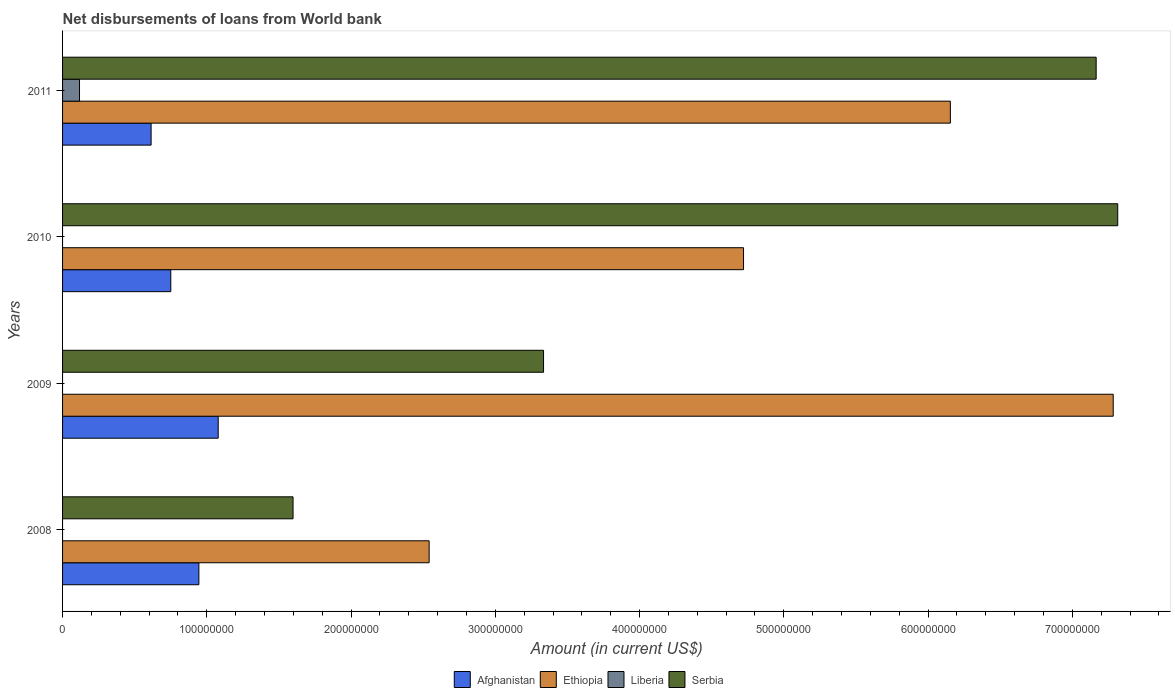How many different coloured bars are there?
Provide a short and direct response. 4. How many groups of bars are there?
Make the answer very short. 4. Are the number of bars on each tick of the Y-axis equal?
Offer a terse response. No. How many bars are there on the 2nd tick from the top?
Your response must be concise. 3. How many bars are there on the 4th tick from the bottom?
Offer a very short reply. 4. What is the label of the 1st group of bars from the top?
Give a very brief answer. 2011. In how many cases, is the number of bars for a given year not equal to the number of legend labels?
Offer a very short reply. 3. What is the amount of loan disbursed from World Bank in Afghanistan in 2008?
Your answer should be very brief. 9.45e+07. Across all years, what is the maximum amount of loan disbursed from World Bank in Liberia?
Make the answer very short. 1.17e+07. Across all years, what is the minimum amount of loan disbursed from World Bank in Afghanistan?
Your answer should be very brief. 6.14e+07. What is the total amount of loan disbursed from World Bank in Liberia in the graph?
Provide a succinct answer. 1.17e+07. What is the difference between the amount of loan disbursed from World Bank in Ethiopia in 2008 and that in 2010?
Your answer should be compact. -2.18e+08. What is the difference between the amount of loan disbursed from World Bank in Afghanistan in 2011 and the amount of loan disbursed from World Bank in Ethiopia in 2008?
Your answer should be very brief. -1.93e+08. What is the average amount of loan disbursed from World Bank in Serbia per year?
Provide a short and direct response. 4.85e+08. In the year 2009, what is the difference between the amount of loan disbursed from World Bank in Ethiopia and amount of loan disbursed from World Bank in Afghanistan?
Provide a succinct answer. 6.20e+08. What is the ratio of the amount of loan disbursed from World Bank in Ethiopia in 2008 to that in 2010?
Keep it short and to the point. 0.54. Is the amount of loan disbursed from World Bank in Serbia in 2008 less than that in 2009?
Make the answer very short. Yes. Is the difference between the amount of loan disbursed from World Bank in Ethiopia in 2008 and 2011 greater than the difference between the amount of loan disbursed from World Bank in Afghanistan in 2008 and 2011?
Make the answer very short. No. What is the difference between the highest and the second highest amount of loan disbursed from World Bank in Afghanistan?
Offer a very short reply. 1.34e+07. What is the difference between the highest and the lowest amount of loan disbursed from World Bank in Serbia?
Offer a very short reply. 5.72e+08. In how many years, is the amount of loan disbursed from World Bank in Afghanistan greater than the average amount of loan disbursed from World Bank in Afghanistan taken over all years?
Provide a succinct answer. 2. Is it the case that in every year, the sum of the amount of loan disbursed from World Bank in Afghanistan and amount of loan disbursed from World Bank in Serbia is greater than the sum of amount of loan disbursed from World Bank in Liberia and amount of loan disbursed from World Bank in Ethiopia?
Your response must be concise. Yes. Is it the case that in every year, the sum of the amount of loan disbursed from World Bank in Serbia and amount of loan disbursed from World Bank in Ethiopia is greater than the amount of loan disbursed from World Bank in Liberia?
Make the answer very short. Yes. How many years are there in the graph?
Offer a terse response. 4. What is the difference between two consecutive major ticks on the X-axis?
Offer a terse response. 1.00e+08. Are the values on the major ticks of X-axis written in scientific E-notation?
Your response must be concise. No. Does the graph contain any zero values?
Offer a terse response. Yes. Does the graph contain grids?
Provide a short and direct response. No. Where does the legend appear in the graph?
Provide a short and direct response. Bottom center. What is the title of the graph?
Your answer should be compact. Net disbursements of loans from World bank. What is the label or title of the Y-axis?
Your answer should be very brief. Years. What is the Amount (in current US$) in Afghanistan in 2008?
Provide a succinct answer. 9.45e+07. What is the Amount (in current US$) in Ethiopia in 2008?
Your answer should be very brief. 2.54e+08. What is the Amount (in current US$) in Serbia in 2008?
Offer a terse response. 1.60e+08. What is the Amount (in current US$) in Afghanistan in 2009?
Give a very brief answer. 1.08e+08. What is the Amount (in current US$) of Ethiopia in 2009?
Your response must be concise. 7.28e+08. What is the Amount (in current US$) in Liberia in 2009?
Keep it short and to the point. 0. What is the Amount (in current US$) of Serbia in 2009?
Your answer should be very brief. 3.33e+08. What is the Amount (in current US$) of Afghanistan in 2010?
Offer a terse response. 7.50e+07. What is the Amount (in current US$) of Ethiopia in 2010?
Offer a very short reply. 4.72e+08. What is the Amount (in current US$) of Serbia in 2010?
Provide a short and direct response. 7.31e+08. What is the Amount (in current US$) in Afghanistan in 2011?
Ensure brevity in your answer.  6.14e+07. What is the Amount (in current US$) of Ethiopia in 2011?
Provide a succinct answer. 6.15e+08. What is the Amount (in current US$) of Liberia in 2011?
Give a very brief answer. 1.17e+07. What is the Amount (in current US$) in Serbia in 2011?
Offer a terse response. 7.17e+08. Across all years, what is the maximum Amount (in current US$) of Afghanistan?
Offer a very short reply. 1.08e+08. Across all years, what is the maximum Amount (in current US$) in Ethiopia?
Offer a very short reply. 7.28e+08. Across all years, what is the maximum Amount (in current US$) of Liberia?
Your response must be concise. 1.17e+07. Across all years, what is the maximum Amount (in current US$) in Serbia?
Make the answer very short. 7.31e+08. Across all years, what is the minimum Amount (in current US$) in Afghanistan?
Your response must be concise. 6.14e+07. Across all years, what is the minimum Amount (in current US$) in Ethiopia?
Provide a short and direct response. 2.54e+08. Across all years, what is the minimum Amount (in current US$) of Serbia?
Your answer should be very brief. 1.60e+08. What is the total Amount (in current US$) of Afghanistan in the graph?
Offer a terse response. 3.39e+08. What is the total Amount (in current US$) in Ethiopia in the graph?
Give a very brief answer. 2.07e+09. What is the total Amount (in current US$) in Liberia in the graph?
Give a very brief answer. 1.17e+07. What is the total Amount (in current US$) in Serbia in the graph?
Keep it short and to the point. 1.94e+09. What is the difference between the Amount (in current US$) in Afghanistan in 2008 and that in 2009?
Keep it short and to the point. -1.34e+07. What is the difference between the Amount (in current US$) of Ethiopia in 2008 and that in 2009?
Ensure brevity in your answer.  -4.74e+08. What is the difference between the Amount (in current US$) in Serbia in 2008 and that in 2009?
Offer a terse response. -1.74e+08. What is the difference between the Amount (in current US$) of Afghanistan in 2008 and that in 2010?
Make the answer very short. 1.95e+07. What is the difference between the Amount (in current US$) in Ethiopia in 2008 and that in 2010?
Provide a short and direct response. -2.18e+08. What is the difference between the Amount (in current US$) in Serbia in 2008 and that in 2010?
Your answer should be compact. -5.72e+08. What is the difference between the Amount (in current US$) in Afghanistan in 2008 and that in 2011?
Your answer should be compact. 3.31e+07. What is the difference between the Amount (in current US$) in Ethiopia in 2008 and that in 2011?
Provide a short and direct response. -3.61e+08. What is the difference between the Amount (in current US$) of Serbia in 2008 and that in 2011?
Provide a short and direct response. -5.57e+08. What is the difference between the Amount (in current US$) of Afghanistan in 2009 and that in 2010?
Your answer should be very brief. 3.29e+07. What is the difference between the Amount (in current US$) in Ethiopia in 2009 and that in 2010?
Provide a succinct answer. 2.56e+08. What is the difference between the Amount (in current US$) in Serbia in 2009 and that in 2010?
Provide a short and direct response. -3.98e+08. What is the difference between the Amount (in current US$) in Afghanistan in 2009 and that in 2011?
Make the answer very short. 4.65e+07. What is the difference between the Amount (in current US$) in Ethiopia in 2009 and that in 2011?
Your response must be concise. 1.13e+08. What is the difference between the Amount (in current US$) of Serbia in 2009 and that in 2011?
Keep it short and to the point. -3.83e+08. What is the difference between the Amount (in current US$) in Afghanistan in 2010 and that in 2011?
Ensure brevity in your answer.  1.37e+07. What is the difference between the Amount (in current US$) in Ethiopia in 2010 and that in 2011?
Offer a terse response. -1.43e+08. What is the difference between the Amount (in current US$) in Serbia in 2010 and that in 2011?
Offer a terse response. 1.50e+07. What is the difference between the Amount (in current US$) in Afghanistan in 2008 and the Amount (in current US$) in Ethiopia in 2009?
Offer a terse response. -6.34e+08. What is the difference between the Amount (in current US$) in Afghanistan in 2008 and the Amount (in current US$) in Serbia in 2009?
Provide a succinct answer. -2.39e+08. What is the difference between the Amount (in current US$) of Ethiopia in 2008 and the Amount (in current US$) of Serbia in 2009?
Provide a short and direct response. -7.93e+07. What is the difference between the Amount (in current US$) in Afghanistan in 2008 and the Amount (in current US$) in Ethiopia in 2010?
Ensure brevity in your answer.  -3.78e+08. What is the difference between the Amount (in current US$) of Afghanistan in 2008 and the Amount (in current US$) of Serbia in 2010?
Make the answer very short. -6.37e+08. What is the difference between the Amount (in current US$) of Ethiopia in 2008 and the Amount (in current US$) of Serbia in 2010?
Make the answer very short. -4.77e+08. What is the difference between the Amount (in current US$) in Afghanistan in 2008 and the Amount (in current US$) in Ethiopia in 2011?
Give a very brief answer. -5.21e+08. What is the difference between the Amount (in current US$) of Afghanistan in 2008 and the Amount (in current US$) of Liberia in 2011?
Provide a succinct answer. 8.28e+07. What is the difference between the Amount (in current US$) in Afghanistan in 2008 and the Amount (in current US$) in Serbia in 2011?
Make the answer very short. -6.22e+08. What is the difference between the Amount (in current US$) of Ethiopia in 2008 and the Amount (in current US$) of Liberia in 2011?
Make the answer very short. 2.42e+08. What is the difference between the Amount (in current US$) in Ethiopia in 2008 and the Amount (in current US$) in Serbia in 2011?
Make the answer very short. -4.62e+08. What is the difference between the Amount (in current US$) in Afghanistan in 2009 and the Amount (in current US$) in Ethiopia in 2010?
Keep it short and to the point. -3.64e+08. What is the difference between the Amount (in current US$) in Afghanistan in 2009 and the Amount (in current US$) in Serbia in 2010?
Your answer should be compact. -6.24e+08. What is the difference between the Amount (in current US$) in Ethiopia in 2009 and the Amount (in current US$) in Serbia in 2010?
Provide a succinct answer. -3.13e+06. What is the difference between the Amount (in current US$) in Afghanistan in 2009 and the Amount (in current US$) in Ethiopia in 2011?
Offer a very short reply. -5.08e+08. What is the difference between the Amount (in current US$) in Afghanistan in 2009 and the Amount (in current US$) in Liberia in 2011?
Your answer should be compact. 9.61e+07. What is the difference between the Amount (in current US$) of Afghanistan in 2009 and the Amount (in current US$) of Serbia in 2011?
Offer a very short reply. -6.09e+08. What is the difference between the Amount (in current US$) in Ethiopia in 2009 and the Amount (in current US$) in Liberia in 2011?
Give a very brief answer. 7.17e+08. What is the difference between the Amount (in current US$) of Ethiopia in 2009 and the Amount (in current US$) of Serbia in 2011?
Provide a succinct answer. 1.18e+07. What is the difference between the Amount (in current US$) in Afghanistan in 2010 and the Amount (in current US$) in Ethiopia in 2011?
Ensure brevity in your answer.  -5.40e+08. What is the difference between the Amount (in current US$) of Afghanistan in 2010 and the Amount (in current US$) of Liberia in 2011?
Offer a terse response. 6.33e+07. What is the difference between the Amount (in current US$) of Afghanistan in 2010 and the Amount (in current US$) of Serbia in 2011?
Your response must be concise. -6.41e+08. What is the difference between the Amount (in current US$) in Ethiopia in 2010 and the Amount (in current US$) in Liberia in 2011?
Make the answer very short. 4.60e+08. What is the difference between the Amount (in current US$) in Ethiopia in 2010 and the Amount (in current US$) in Serbia in 2011?
Provide a short and direct response. -2.44e+08. What is the average Amount (in current US$) in Afghanistan per year?
Provide a succinct answer. 8.47e+07. What is the average Amount (in current US$) of Ethiopia per year?
Offer a very short reply. 5.18e+08. What is the average Amount (in current US$) of Liberia per year?
Offer a very short reply. 2.94e+06. What is the average Amount (in current US$) of Serbia per year?
Give a very brief answer. 4.85e+08. In the year 2008, what is the difference between the Amount (in current US$) of Afghanistan and Amount (in current US$) of Ethiopia?
Offer a terse response. -1.60e+08. In the year 2008, what is the difference between the Amount (in current US$) in Afghanistan and Amount (in current US$) in Serbia?
Ensure brevity in your answer.  -6.53e+07. In the year 2008, what is the difference between the Amount (in current US$) in Ethiopia and Amount (in current US$) in Serbia?
Your answer should be compact. 9.43e+07. In the year 2009, what is the difference between the Amount (in current US$) in Afghanistan and Amount (in current US$) in Ethiopia?
Provide a succinct answer. -6.20e+08. In the year 2009, what is the difference between the Amount (in current US$) of Afghanistan and Amount (in current US$) of Serbia?
Ensure brevity in your answer.  -2.26e+08. In the year 2009, what is the difference between the Amount (in current US$) of Ethiopia and Amount (in current US$) of Serbia?
Ensure brevity in your answer.  3.95e+08. In the year 2010, what is the difference between the Amount (in current US$) of Afghanistan and Amount (in current US$) of Ethiopia?
Provide a short and direct response. -3.97e+08. In the year 2010, what is the difference between the Amount (in current US$) in Afghanistan and Amount (in current US$) in Serbia?
Ensure brevity in your answer.  -6.56e+08. In the year 2010, what is the difference between the Amount (in current US$) of Ethiopia and Amount (in current US$) of Serbia?
Keep it short and to the point. -2.59e+08. In the year 2011, what is the difference between the Amount (in current US$) in Afghanistan and Amount (in current US$) in Ethiopia?
Give a very brief answer. -5.54e+08. In the year 2011, what is the difference between the Amount (in current US$) of Afghanistan and Amount (in current US$) of Liberia?
Offer a terse response. 4.96e+07. In the year 2011, what is the difference between the Amount (in current US$) of Afghanistan and Amount (in current US$) of Serbia?
Offer a very short reply. -6.55e+08. In the year 2011, what is the difference between the Amount (in current US$) in Ethiopia and Amount (in current US$) in Liberia?
Make the answer very short. 6.04e+08. In the year 2011, what is the difference between the Amount (in current US$) in Ethiopia and Amount (in current US$) in Serbia?
Make the answer very short. -1.01e+08. In the year 2011, what is the difference between the Amount (in current US$) of Liberia and Amount (in current US$) of Serbia?
Keep it short and to the point. -7.05e+08. What is the ratio of the Amount (in current US$) in Afghanistan in 2008 to that in 2009?
Ensure brevity in your answer.  0.88. What is the ratio of the Amount (in current US$) in Ethiopia in 2008 to that in 2009?
Your answer should be compact. 0.35. What is the ratio of the Amount (in current US$) in Serbia in 2008 to that in 2009?
Offer a very short reply. 0.48. What is the ratio of the Amount (in current US$) in Afghanistan in 2008 to that in 2010?
Provide a succinct answer. 1.26. What is the ratio of the Amount (in current US$) of Ethiopia in 2008 to that in 2010?
Offer a terse response. 0.54. What is the ratio of the Amount (in current US$) of Serbia in 2008 to that in 2010?
Offer a terse response. 0.22. What is the ratio of the Amount (in current US$) in Afghanistan in 2008 to that in 2011?
Keep it short and to the point. 1.54. What is the ratio of the Amount (in current US$) of Ethiopia in 2008 to that in 2011?
Make the answer very short. 0.41. What is the ratio of the Amount (in current US$) in Serbia in 2008 to that in 2011?
Make the answer very short. 0.22. What is the ratio of the Amount (in current US$) in Afghanistan in 2009 to that in 2010?
Your response must be concise. 1.44. What is the ratio of the Amount (in current US$) of Ethiopia in 2009 to that in 2010?
Your answer should be compact. 1.54. What is the ratio of the Amount (in current US$) in Serbia in 2009 to that in 2010?
Keep it short and to the point. 0.46. What is the ratio of the Amount (in current US$) of Afghanistan in 2009 to that in 2011?
Offer a terse response. 1.76. What is the ratio of the Amount (in current US$) in Ethiopia in 2009 to that in 2011?
Offer a very short reply. 1.18. What is the ratio of the Amount (in current US$) of Serbia in 2009 to that in 2011?
Make the answer very short. 0.47. What is the ratio of the Amount (in current US$) in Afghanistan in 2010 to that in 2011?
Keep it short and to the point. 1.22. What is the ratio of the Amount (in current US$) of Ethiopia in 2010 to that in 2011?
Make the answer very short. 0.77. What is the ratio of the Amount (in current US$) in Serbia in 2010 to that in 2011?
Keep it short and to the point. 1.02. What is the difference between the highest and the second highest Amount (in current US$) in Afghanistan?
Give a very brief answer. 1.34e+07. What is the difference between the highest and the second highest Amount (in current US$) of Ethiopia?
Your answer should be very brief. 1.13e+08. What is the difference between the highest and the second highest Amount (in current US$) of Serbia?
Provide a short and direct response. 1.50e+07. What is the difference between the highest and the lowest Amount (in current US$) in Afghanistan?
Ensure brevity in your answer.  4.65e+07. What is the difference between the highest and the lowest Amount (in current US$) of Ethiopia?
Your answer should be very brief. 4.74e+08. What is the difference between the highest and the lowest Amount (in current US$) of Liberia?
Provide a short and direct response. 1.17e+07. What is the difference between the highest and the lowest Amount (in current US$) of Serbia?
Provide a succinct answer. 5.72e+08. 